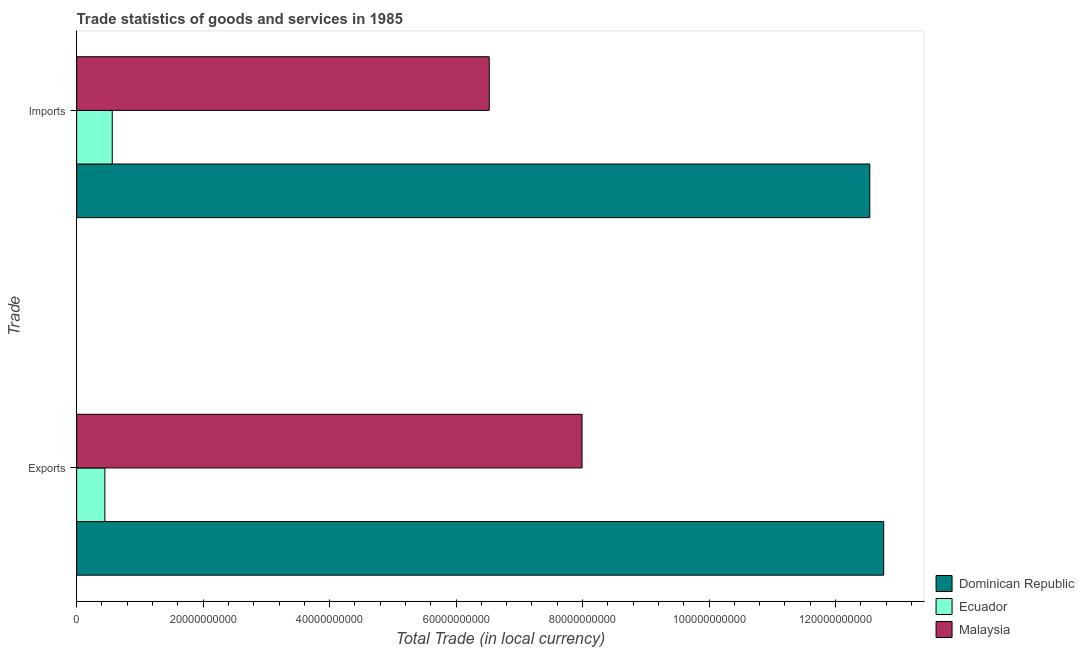How many different coloured bars are there?
Make the answer very short. 3. How many groups of bars are there?
Offer a very short reply. 2. How many bars are there on the 1st tick from the bottom?
Your answer should be compact. 3. What is the label of the 2nd group of bars from the top?
Offer a terse response. Exports. What is the export of goods and services in Malaysia?
Your answer should be very brief. 7.99e+1. Across all countries, what is the maximum imports of goods and services?
Give a very brief answer. 1.25e+11. Across all countries, what is the minimum export of goods and services?
Offer a very short reply. 4.46e+09. In which country was the export of goods and services maximum?
Your answer should be compact. Dominican Republic. In which country was the imports of goods and services minimum?
Your answer should be very brief. Ecuador. What is the total export of goods and services in the graph?
Your answer should be very brief. 2.12e+11. What is the difference between the export of goods and services in Malaysia and that in Ecuador?
Offer a very short reply. 7.55e+1. What is the difference between the export of goods and services in Dominican Republic and the imports of goods and services in Ecuador?
Ensure brevity in your answer.  1.22e+11. What is the average imports of goods and services per country?
Your answer should be compact. 6.54e+1. What is the difference between the export of goods and services and imports of goods and services in Dominican Republic?
Provide a succinct answer. 2.20e+09. What is the ratio of the imports of goods and services in Malaysia to that in Dominican Republic?
Your answer should be very brief. 0.52. In how many countries, is the imports of goods and services greater than the average imports of goods and services taken over all countries?
Keep it short and to the point. 1. What does the 1st bar from the top in Exports represents?
Give a very brief answer. Malaysia. What does the 1st bar from the bottom in Imports represents?
Ensure brevity in your answer.  Dominican Republic. Are all the bars in the graph horizontal?
Your answer should be compact. Yes. What is the difference between two consecutive major ticks on the X-axis?
Provide a succinct answer. 2.00e+1. Does the graph contain grids?
Ensure brevity in your answer.  No. Where does the legend appear in the graph?
Your answer should be compact. Bottom right. What is the title of the graph?
Provide a short and direct response. Trade statistics of goods and services in 1985. Does "Lebanon" appear as one of the legend labels in the graph?
Keep it short and to the point. No. What is the label or title of the X-axis?
Your answer should be compact. Total Trade (in local currency). What is the label or title of the Y-axis?
Your response must be concise. Trade. What is the Total Trade (in local currency) in Dominican Republic in Exports?
Provide a succinct answer. 1.28e+11. What is the Total Trade (in local currency) in Ecuador in Exports?
Your answer should be compact. 4.46e+09. What is the Total Trade (in local currency) in Malaysia in Exports?
Your answer should be very brief. 7.99e+1. What is the Total Trade (in local currency) in Dominican Republic in Imports?
Offer a very short reply. 1.25e+11. What is the Total Trade (in local currency) in Ecuador in Imports?
Your answer should be very brief. 5.63e+09. What is the Total Trade (in local currency) of Malaysia in Imports?
Your response must be concise. 6.52e+1. Across all Trade, what is the maximum Total Trade (in local currency) in Dominican Republic?
Ensure brevity in your answer.  1.28e+11. Across all Trade, what is the maximum Total Trade (in local currency) of Ecuador?
Give a very brief answer. 5.63e+09. Across all Trade, what is the maximum Total Trade (in local currency) of Malaysia?
Provide a succinct answer. 7.99e+1. Across all Trade, what is the minimum Total Trade (in local currency) of Dominican Republic?
Your answer should be compact. 1.25e+11. Across all Trade, what is the minimum Total Trade (in local currency) of Ecuador?
Provide a succinct answer. 4.46e+09. Across all Trade, what is the minimum Total Trade (in local currency) in Malaysia?
Your answer should be compact. 6.52e+1. What is the total Total Trade (in local currency) of Dominican Republic in the graph?
Keep it short and to the point. 2.53e+11. What is the total Total Trade (in local currency) in Ecuador in the graph?
Ensure brevity in your answer.  1.01e+1. What is the total Total Trade (in local currency) of Malaysia in the graph?
Make the answer very short. 1.45e+11. What is the difference between the Total Trade (in local currency) in Dominican Republic in Exports and that in Imports?
Ensure brevity in your answer.  2.20e+09. What is the difference between the Total Trade (in local currency) of Ecuador in Exports and that in Imports?
Your response must be concise. -1.17e+09. What is the difference between the Total Trade (in local currency) in Malaysia in Exports and that in Imports?
Keep it short and to the point. 1.47e+1. What is the difference between the Total Trade (in local currency) of Dominican Republic in Exports and the Total Trade (in local currency) of Ecuador in Imports?
Provide a short and direct response. 1.22e+11. What is the difference between the Total Trade (in local currency) in Dominican Republic in Exports and the Total Trade (in local currency) in Malaysia in Imports?
Your response must be concise. 6.24e+1. What is the difference between the Total Trade (in local currency) of Ecuador in Exports and the Total Trade (in local currency) of Malaysia in Imports?
Give a very brief answer. -6.08e+1. What is the average Total Trade (in local currency) of Dominican Republic per Trade?
Provide a succinct answer. 1.27e+11. What is the average Total Trade (in local currency) of Ecuador per Trade?
Your answer should be very brief. 5.05e+09. What is the average Total Trade (in local currency) of Malaysia per Trade?
Your answer should be compact. 7.26e+1. What is the difference between the Total Trade (in local currency) of Dominican Republic and Total Trade (in local currency) of Ecuador in Exports?
Offer a terse response. 1.23e+11. What is the difference between the Total Trade (in local currency) of Dominican Republic and Total Trade (in local currency) of Malaysia in Exports?
Offer a very short reply. 4.77e+1. What is the difference between the Total Trade (in local currency) in Ecuador and Total Trade (in local currency) in Malaysia in Exports?
Your answer should be very brief. -7.55e+1. What is the difference between the Total Trade (in local currency) in Dominican Republic and Total Trade (in local currency) in Ecuador in Imports?
Offer a very short reply. 1.20e+11. What is the difference between the Total Trade (in local currency) in Dominican Republic and Total Trade (in local currency) in Malaysia in Imports?
Make the answer very short. 6.02e+1. What is the difference between the Total Trade (in local currency) in Ecuador and Total Trade (in local currency) in Malaysia in Imports?
Make the answer very short. -5.96e+1. What is the ratio of the Total Trade (in local currency) in Dominican Republic in Exports to that in Imports?
Ensure brevity in your answer.  1.02. What is the ratio of the Total Trade (in local currency) in Ecuador in Exports to that in Imports?
Your response must be concise. 0.79. What is the ratio of the Total Trade (in local currency) in Malaysia in Exports to that in Imports?
Keep it short and to the point. 1.23. What is the difference between the highest and the second highest Total Trade (in local currency) in Dominican Republic?
Your response must be concise. 2.20e+09. What is the difference between the highest and the second highest Total Trade (in local currency) in Ecuador?
Provide a short and direct response. 1.17e+09. What is the difference between the highest and the second highest Total Trade (in local currency) of Malaysia?
Make the answer very short. 1.47e+1. What is the difference between the highest and the lowest Total Trade (in local currency) in Dominican Republic?
Give a very brief answer. 2.20e+09. What is the difference between the highest and the lowest Total Trade (in local currency) in Ecuador?
Provide a short and direct response. 1.17e+09. What is the difference between the highest and the lowest Total Trade (in local currency) in Malaysia?
Provide a short and direct response. 1.47e+1. 